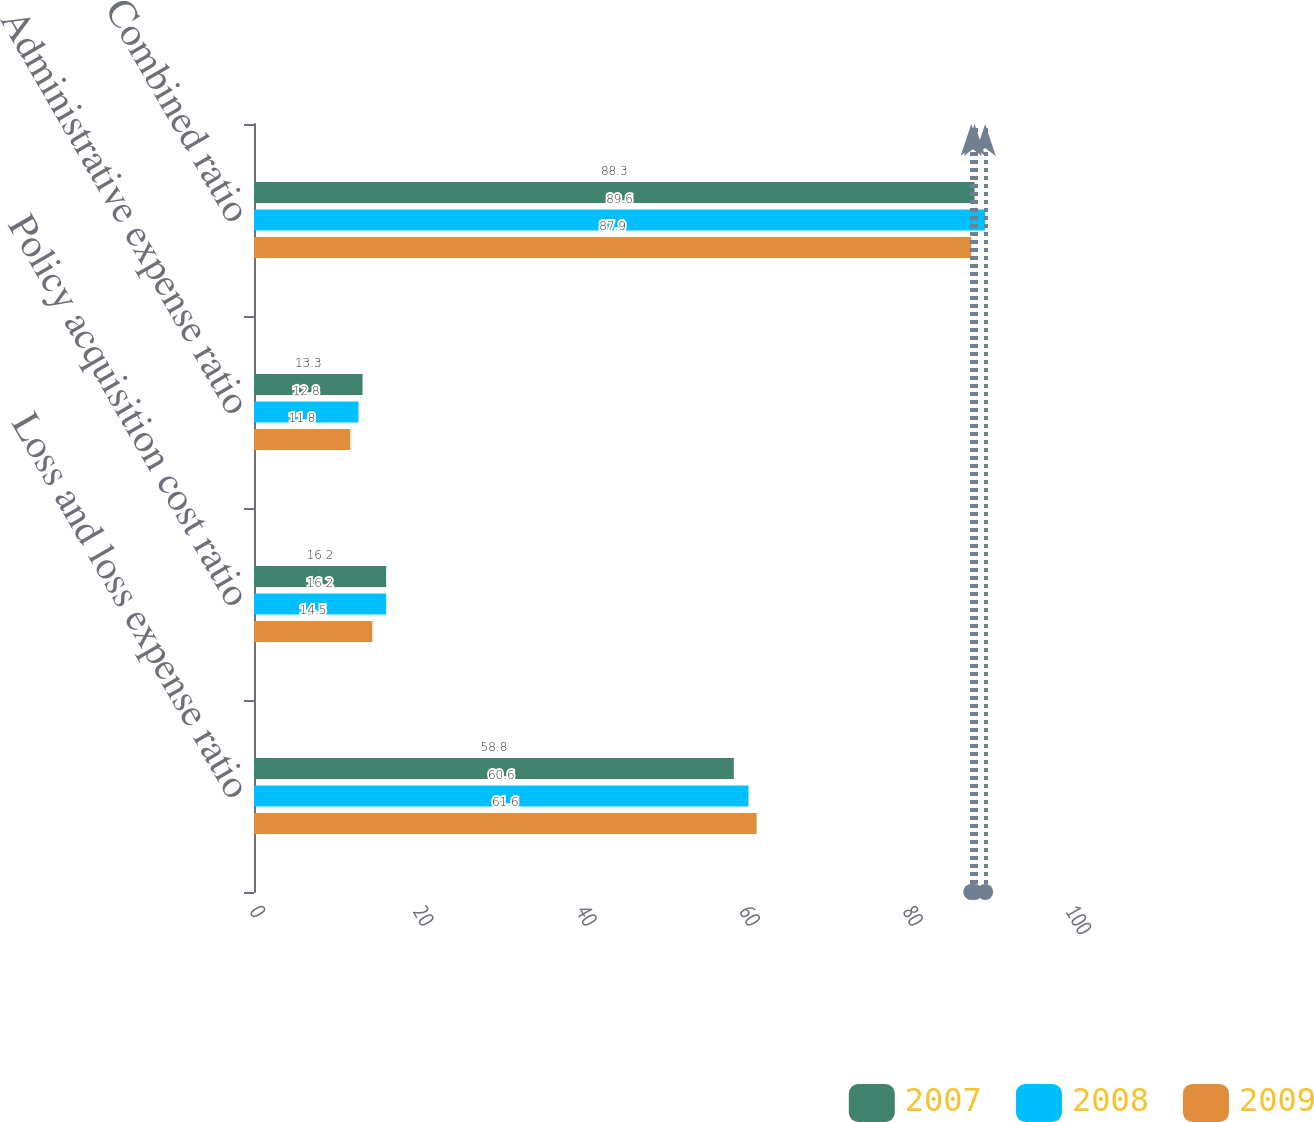Convert chart to OTSL. <chart><loc_0><loc_0><loc_500><loc_500><stacked_bar_chart><ecel><fcel>Loss and loss expense ratio<fcel>Policy acquisition cost ratio<fcel>Administrative expense ratio<fcel>Combined ratio<nl><fcel>2007<fcel>58.8<fcel>16.2<fcel>13.3<fcel>88.3<nl><fcel>2008<fcel>60.6<fcel>16.2<fcel>12.8<fcel>89.6<nl><fcel>2009<fcel>61.6<fcel>14.5<fcel>11.8<fcel>87.9<nl></chart> 